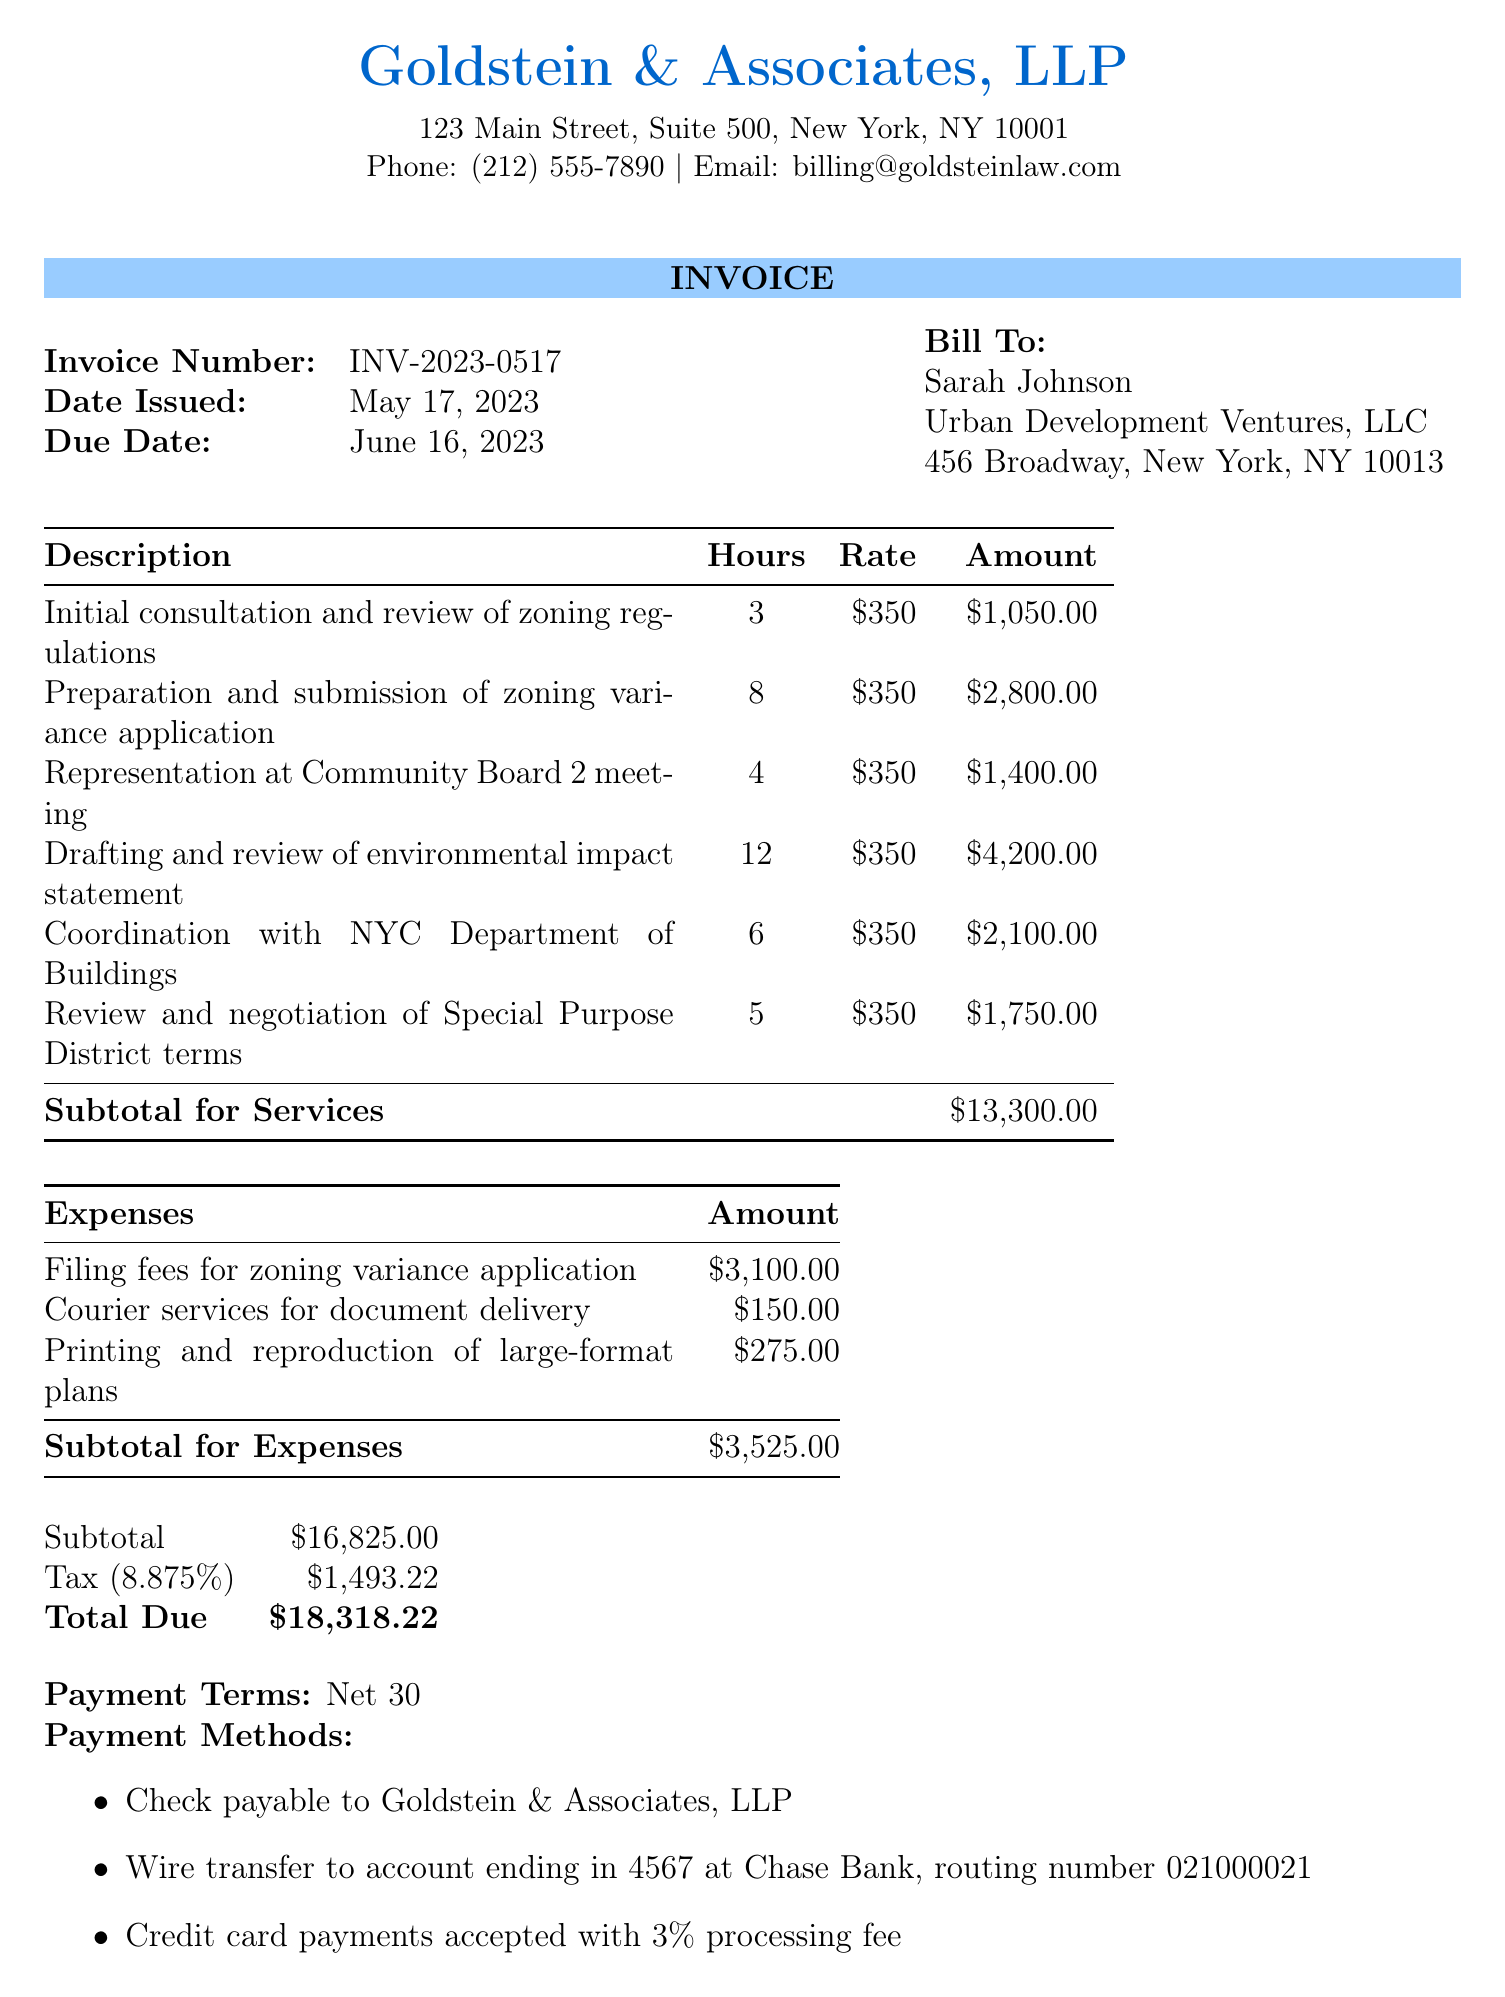What is the invoice number? The invoice number is specified as INV-2023-0517 in the document.
Answer: INV-2023-0517 Who is the client? The client's name is mentioned as Sarah Johnson in the document.
Answer: Sarah Johnson What is the total amount due? The total due is calculated at the end of the document and is stated as $18,318.22.
Answer: $18,318.22 What is the tax rate? The tax rate is clearly indicated as 8.875% in the document.
Answer: 8.875% How many hours were spent on drafting the environmental impact statement? The number of hours for this service is listed as 12 in the services section.
Answer: 12 What method of payment incurs a processing fee? The document specifies that credit card payments incur a 3% processing fee.
Answer: Credit card payments What is the due date for the payment? The due date is mentioned as June 16, 2023, in the invoice.
Answer: June 16, 2023 What is included in the expenses? The types of expenses listed include filing fees, courier services, and printing costs.
Answer: Filing fees, courier services, printing costs How many hours were devoted to the initial consultation? It is stated that 3 hours were allocated for the initial consultation in the document.
Answer: 3 